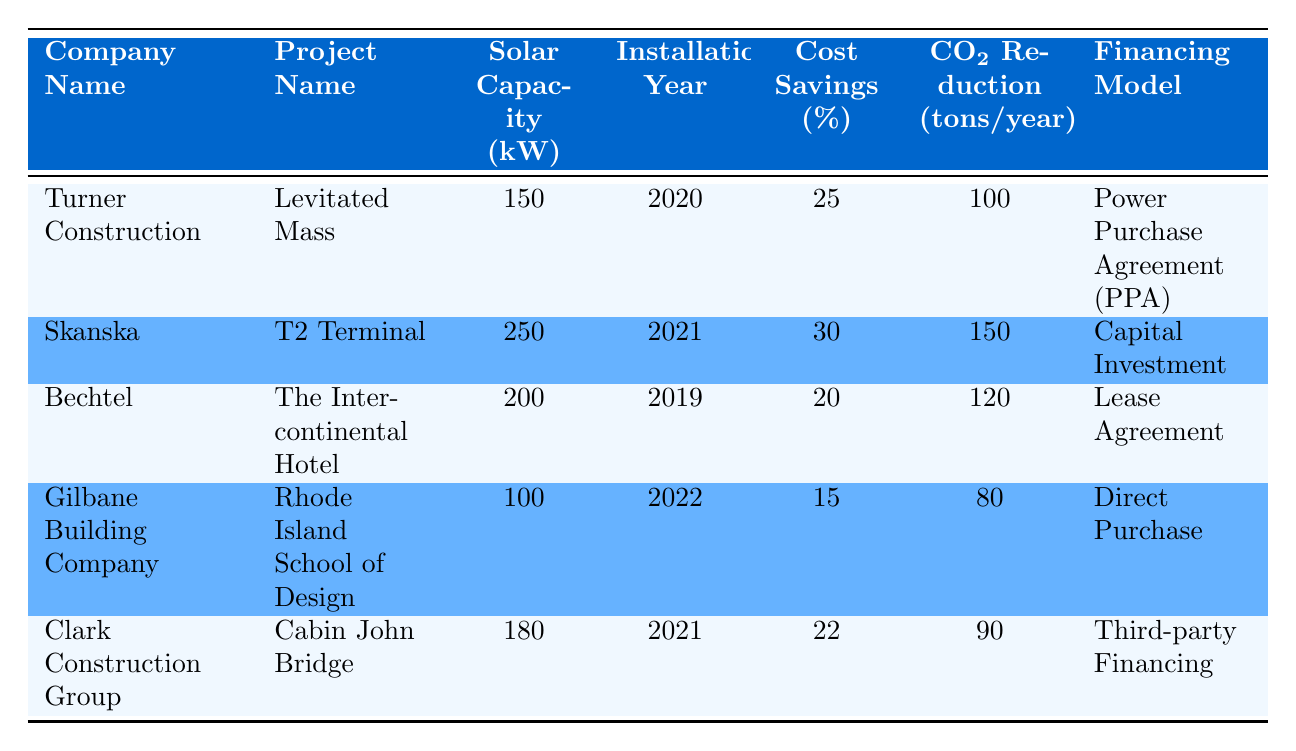What is the solar capacity of Gilbane Building Company? The table lists Gilbane Building Company with a solar capacity of 100 kW.
Answer: 100 kW Which company achieved the highest cost savings percentage? By comparing the cost savings percentages across the companies, Skanska has the highest percentage at 30%.
Answer: Skanska What is the total CO2 reduction from all projects combined? To find the total CO2 reduction, sum the individual reductions: 100 + 150 + 120 + 80 + 90 = 540 tons/year.
Answer: 540 tons/year Did Bechtel have any cost savings less than 25%? Bechtel had 20% cost savings, which is less than 25%.
Answer: Yes Which financing model was used by Turner Construction? The table indicates that Turner Construction used a Power Purchase Agreement (PPA) for financing.
Answer: Power Purchase Agreement (PPA) What is the average solar capacity of the companies listed? To calculate the average, add the solar capacities: 150 + 250 + 200 + 100 + 180 = 880 kW. Then divide by the number of companies, which is 5: 880/5 = 176 kW.
Answer: 176 kW Is Clark Construction Group's project the newest installation? Clark Construction Group's project was installed in 2021, while the latest project in the table is by Gilbane Building Company in 2022.
Answer: No How much more CO2 reduction did Skanska achieve compared to Gilbane Building Company? Skanska’s CO2 reduction is 150 tons/year, while Gilbane Building Company’s is 80 tons/year. The difference is 150 - 80 = 70 tons/year.
Answer: 70 tons/year Which company has the least solar capacity? Among the companies listed, Gilbane Building Company has the least solar capacity at 100 kW.
Answer: Gilbane Building Company 